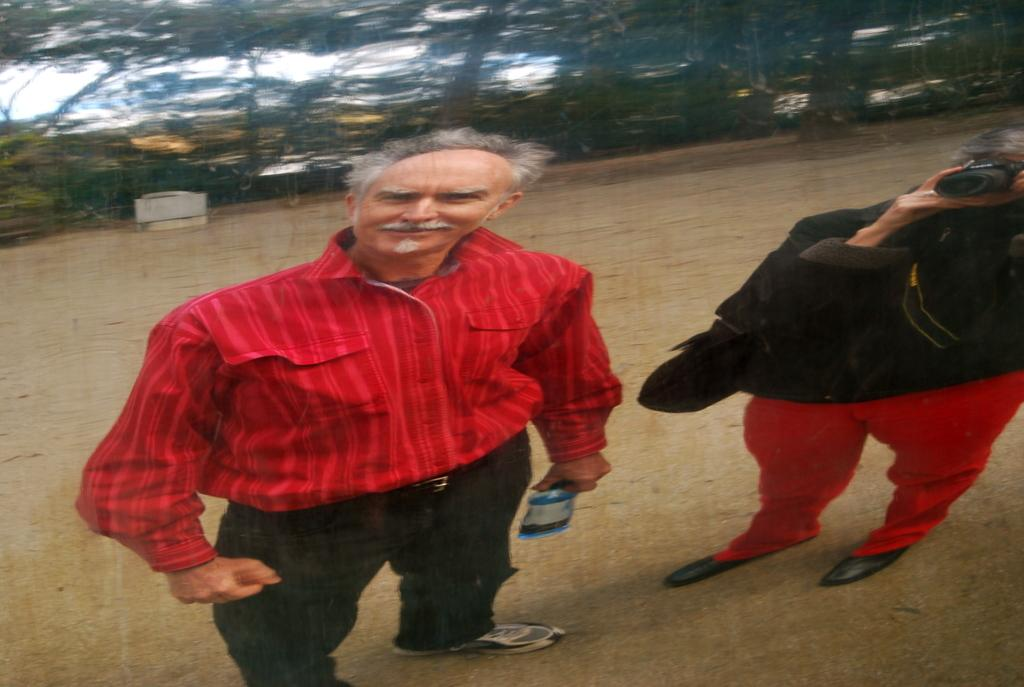How many people are present in the image? There are two people standing on the ground in the image. What objects can be seen in the image besides the people? There is a bottle, a camera, and a bag in the image. What type of natural environment is visible in the image? There are trees in the image, indicating a natural setting. What is visible in the background of the image? The sky is visible in the background of the image. What type of ear is visible on the person in the image? There is no ear visible on the person in the image; only their body and clothing can be seen. Who is the friend of the person in the image? There is no information about friends or relationships in the image, so it cannot be determined. 